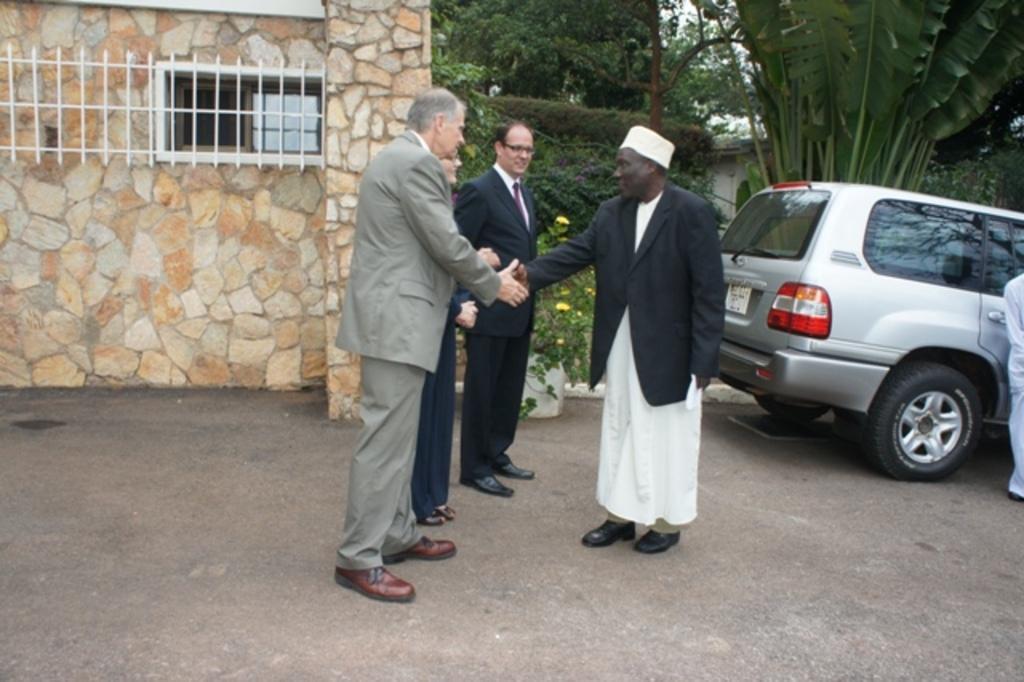Could you give a brief overview of what you see in this image? In this picture I can see there are few people standing and shaking their hands and in the backdrop there is a car, plants, trees and a building. 